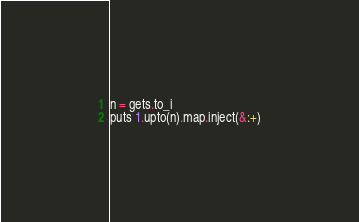<code> <loc_0><loc_0><loc_500><loc_500><_Ruby_>n = gets.to_i
puts 1.upto(n).map.inject(&:+)</code> 